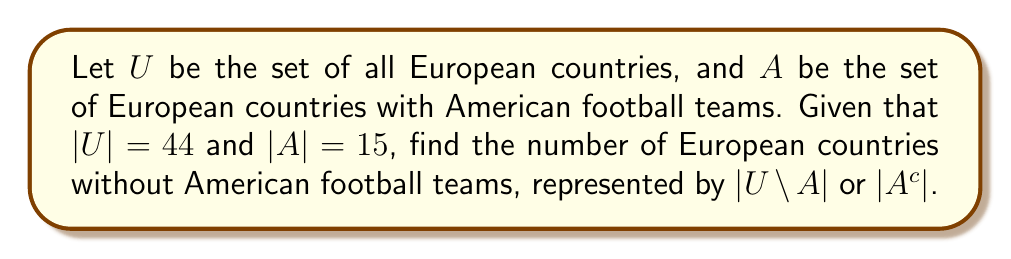What is the answer to this math problem? To solve this problem, we'll use the concept of set complement and basic set theory principles:

1) The complement of set $A$ with respect to the universal set $U$ is denoted as $A^c$ or $U \setminus A$.

2) A fundamental property of set theory states that for any set $A$ in a universal set $U$:

   $$|U| = |A| + |A^c|$$

3) We're given that:
   - $|U| = 44$ (total number of European countries)
   - $|A| = 15$ (number of European countries with American football teams)

4) Substituting these values into the equation from step 2:

   $$44 = 15 + |A^c|$$

5) Solving for $|A^c|$:

   $$|A^c| = 44 - 15 = 29$$

Therefore, there are 29 European countries without American football teams.
Answer: $|A^c| = 29$ 